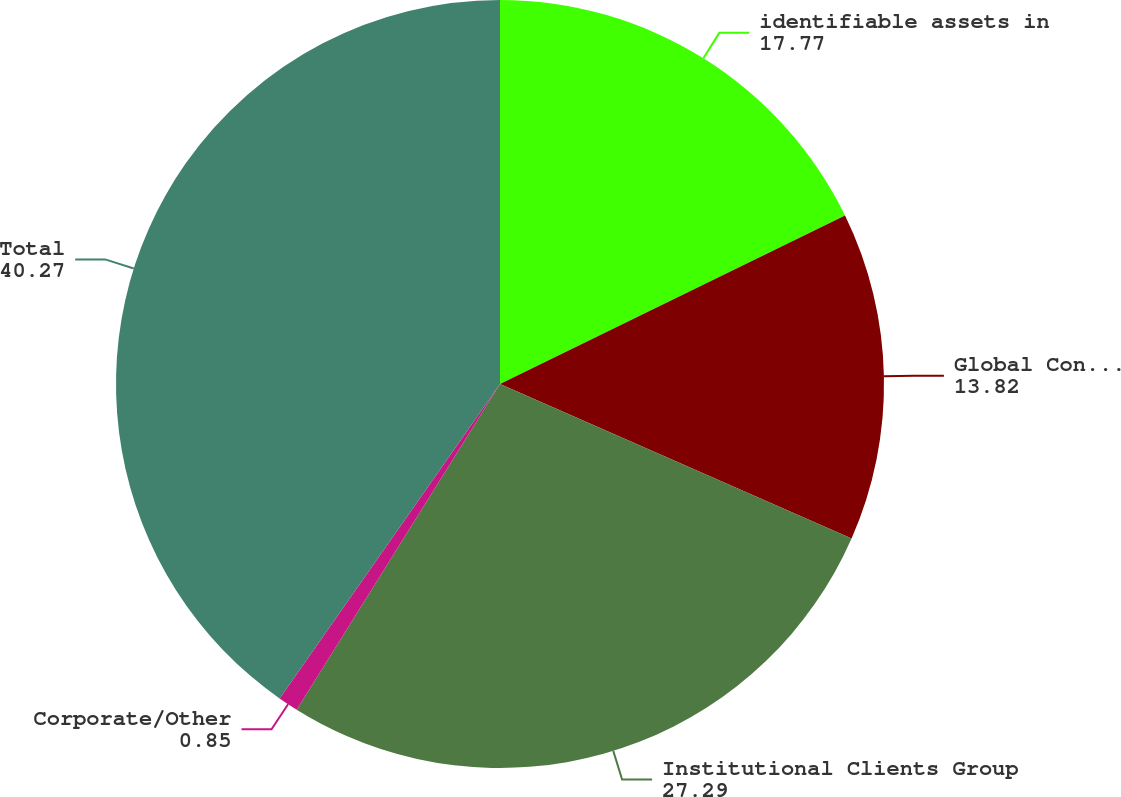<chart> <loc_0><loc_0><loc_500><loc_500><pie_chart><fcel>identifiable assets in<fcel>Global Consumer Banking<fcel>Institutional Clients Group<fcel>Corporate/Other<fcel>Total<nl><fcel>17.77%<fcel>13.82%<fcel>27.29%<fcel>0.85%<fcel>40.27%<nl></chart> 